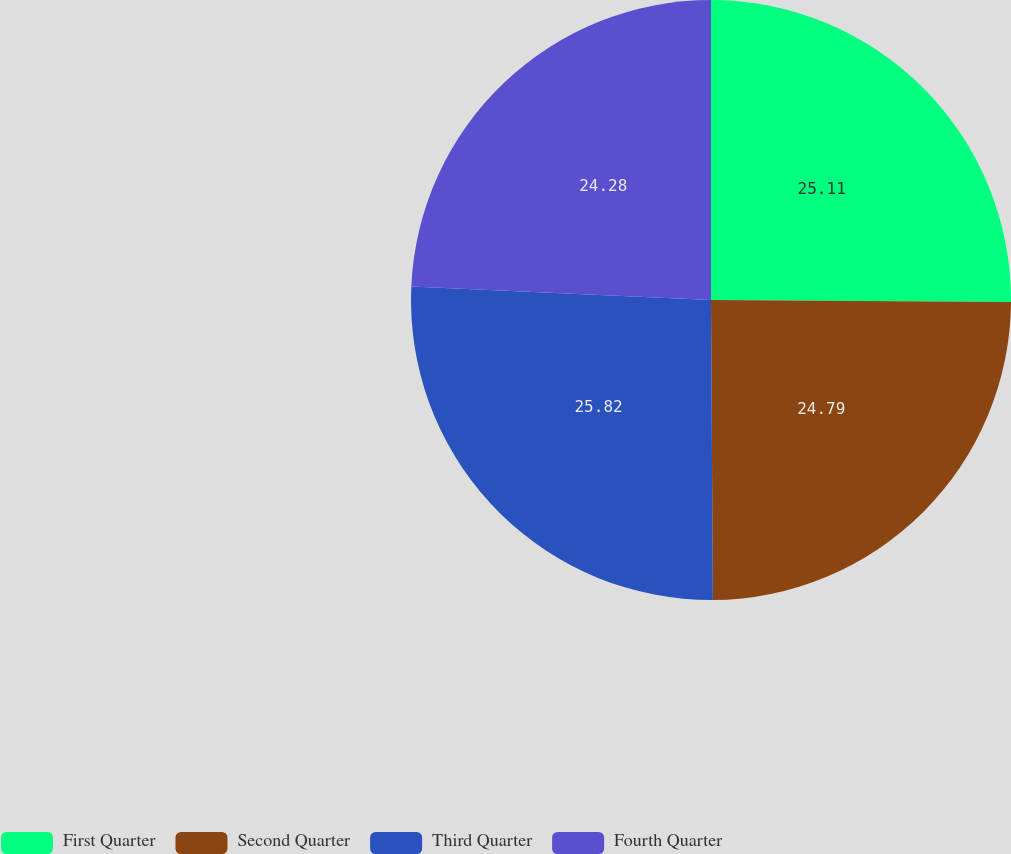Convert chart to OTSL. <chart><loc_0><loc_0><loc_500><loc_500><pie_chart><fcel>First Quarter<fcel>Second Quarter<fcel>Third Quarter<fcel>Fourth Quarter<nl><fcel>25.11%<fcel>24.79%<fcel>25.82%<fcel>24.28%<nl></chart> 